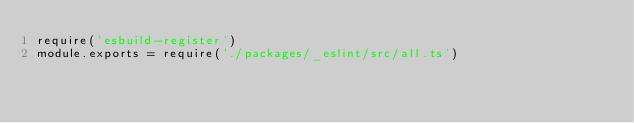<code> <loc_0><loc_0><loc_500><loc_500><_JavaScript_>require('esbuild-register')
module.exports = require('./packages/_eslint/src/all.ts')
</code> 